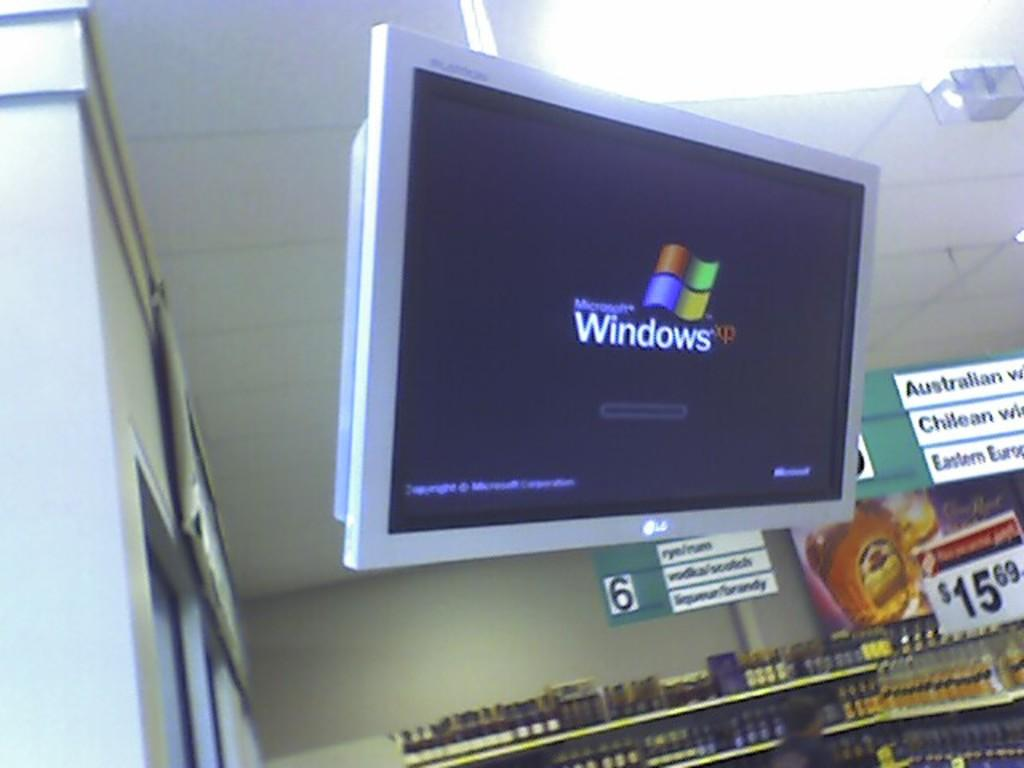<image>
Describe the image concisely. A monitor with the screen showing the Windows logo is mounted to the ceiling of a store. 